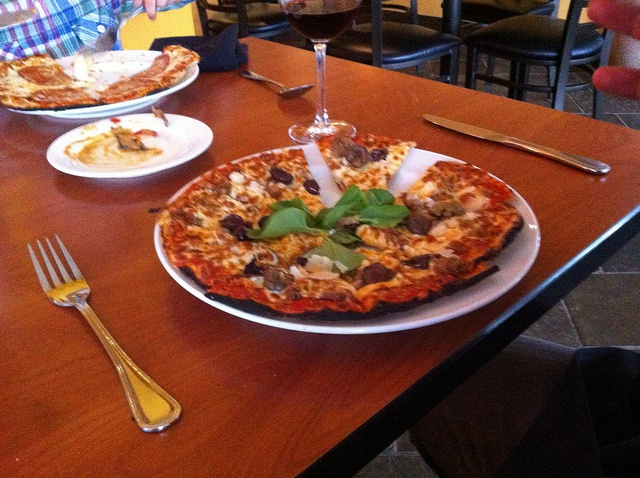Describe the objects in this image and their specific colors. I can see dining table in lightblue, brown, maroon, and black tones, pizza in lightblue, brown, maroon, and tan tones, people in lightblue, black, and gray tones, chair in lightblue, black, and gray tones, and people in lightblue, darkgray, and lavender tones in this image. 